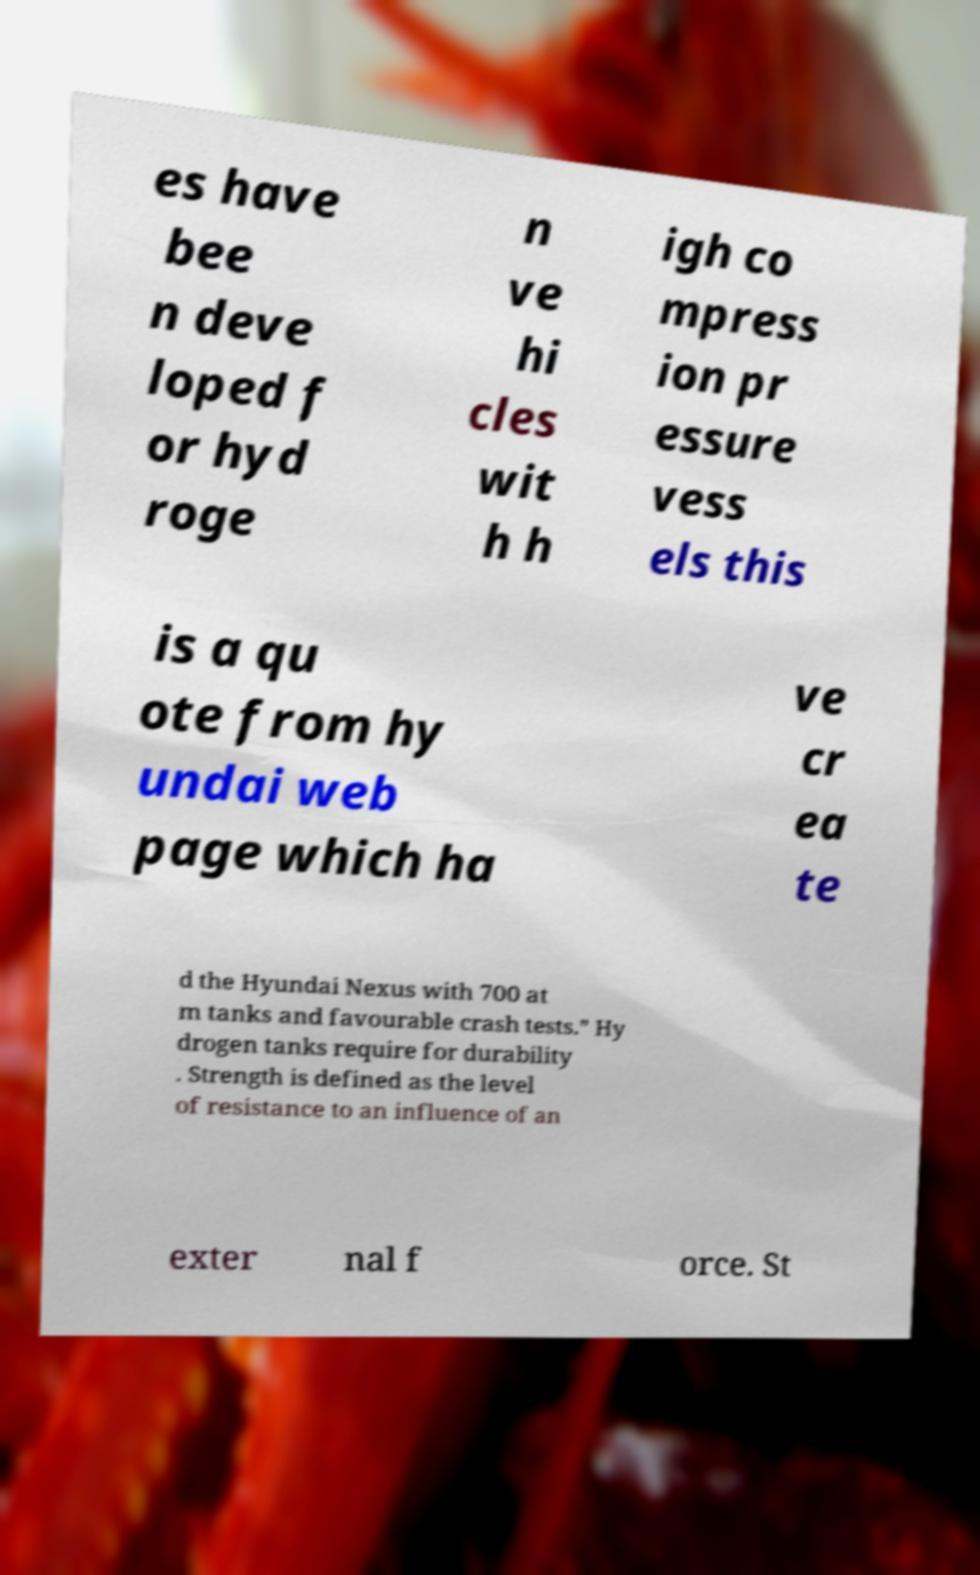I need the written content from this picture converted into text. Can you do that? es have bee n deve loped f or hyd roge n ve hi cles wit h h igh co mpress ion pr essure vess els this is a qu ote from hy undai web page which ha ve cr ea te d the Hyundai Nexus with 700 at m tanks and favourable crash tests.” Hy drogen tanks require for durability . Strength is defined as the level of resistance to an influence of an exter nal f orce. St 